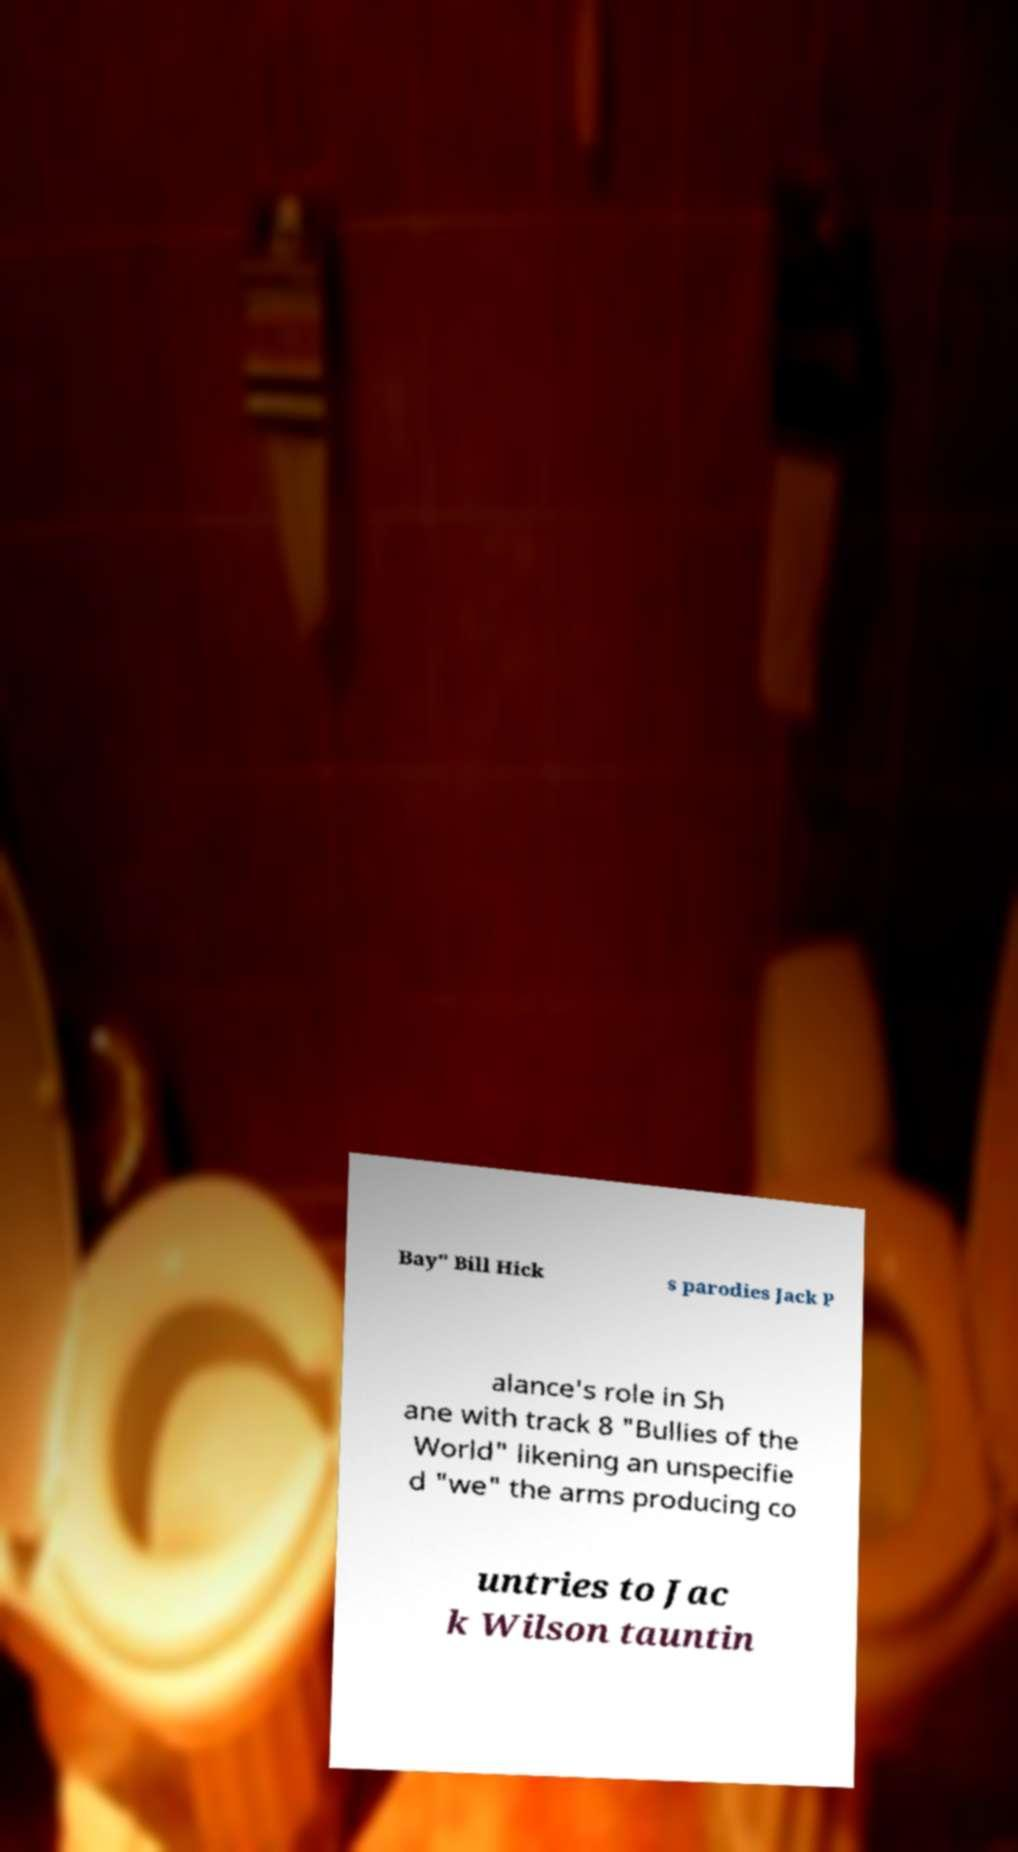Can you accurately transcribe the text from the provided image for me? Bay" Bill Hick s parodies Jack P alance's role in Sh ane with track 8 "Bullies of the World" likening an unspecifie d "we" the arms producing co untries to Jac k Wilson tauntin 